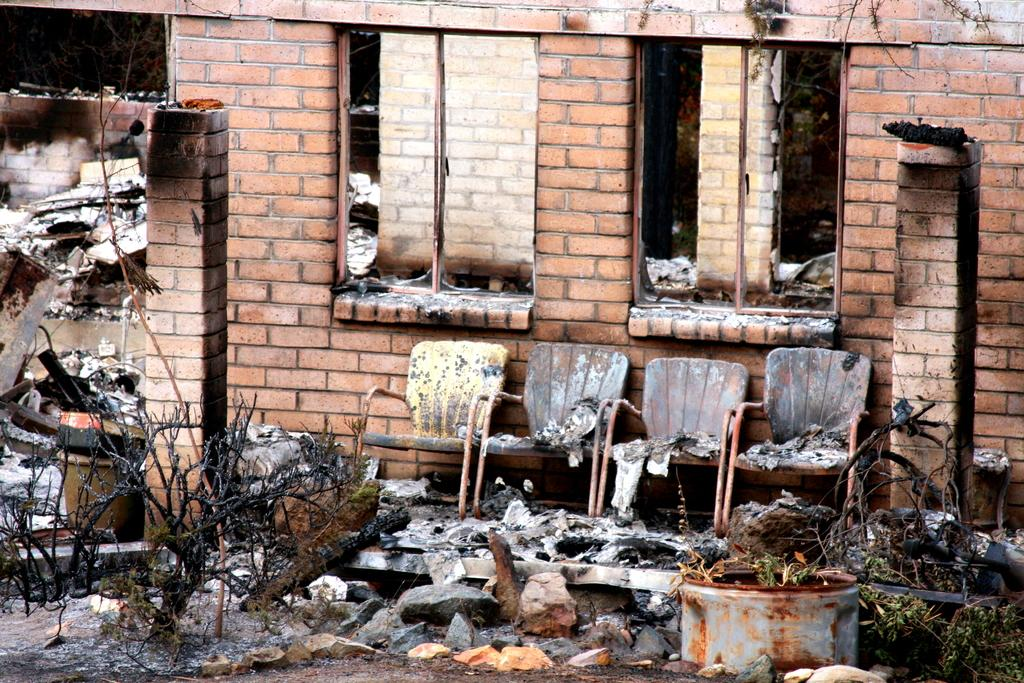What type of living organisms can be seen in the image? Plants are visible in the image. What type of structures can be seen in the image? Walls, windows, and chairs are present in the image. What other objects are present in the image besides plants, walls, windows, and chairs? Other objects are present in the image, but their specific nature is not mentioned in the facts. How are the objects in the image affected by the fire? The objects are damaged due to fire. What is the color of the background in the image? The background of the image is dark in color. How many pizzas are being served on the ship in the image? There is no mention of pizzas or a ship in the image, so this question cannot be answered. What type of pump is used to extinguish the fire in the image? There is no mention of a fire pump or any firefighting equipment in the image, so this question cannot be answered. 